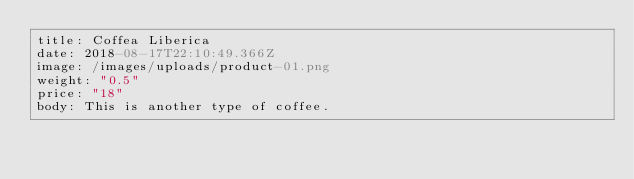Convert code to text. <code><loc_0><loc_0><loc_500><loc_500><_YAML_>title: Coffea Liberica
date: 2018-08-17T22:10:49.366Z
image: /images/uploads/product-01.png
weight: "0.5"
price: "18"
body: This is another type of coffee.
</code> 